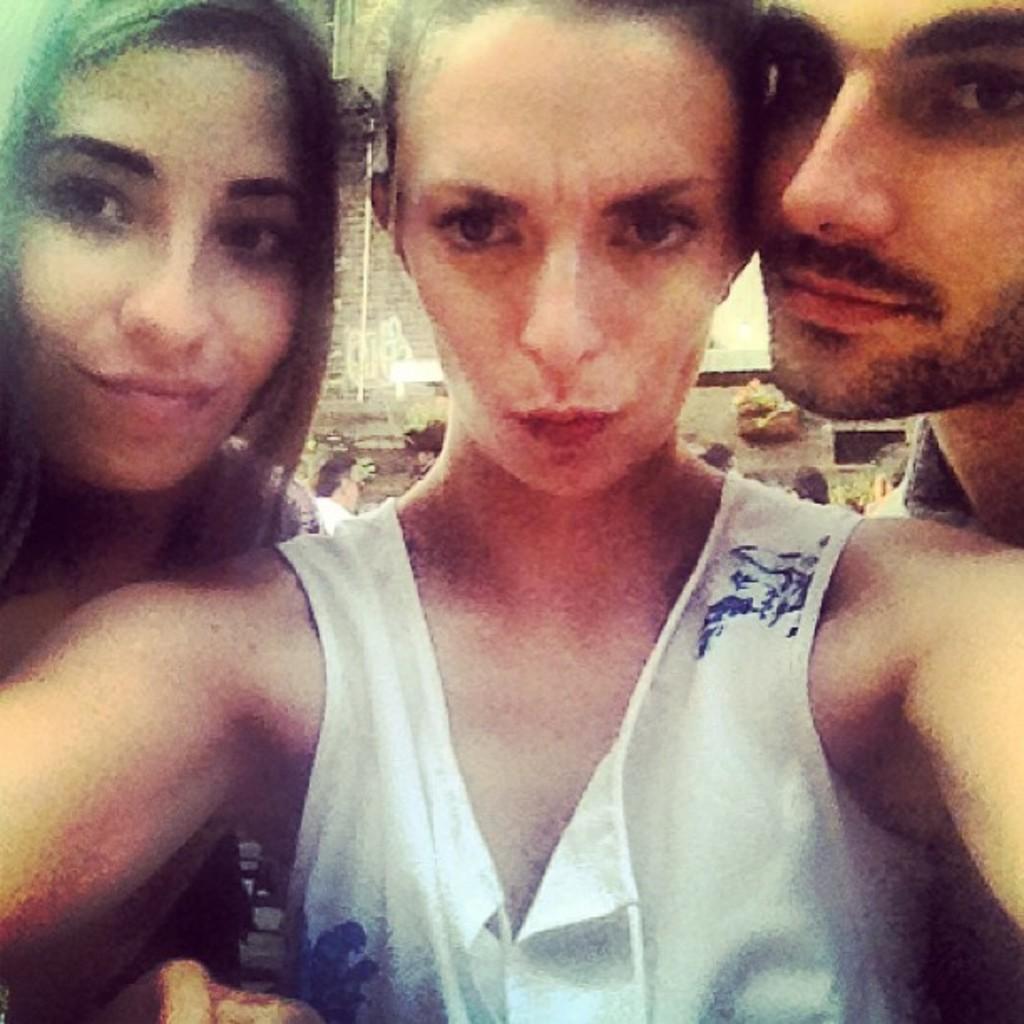In one or two sentences, can you explain what this image depicts? This picture shows a couple of women and a man standing and we see a woman wore a white color dress. 